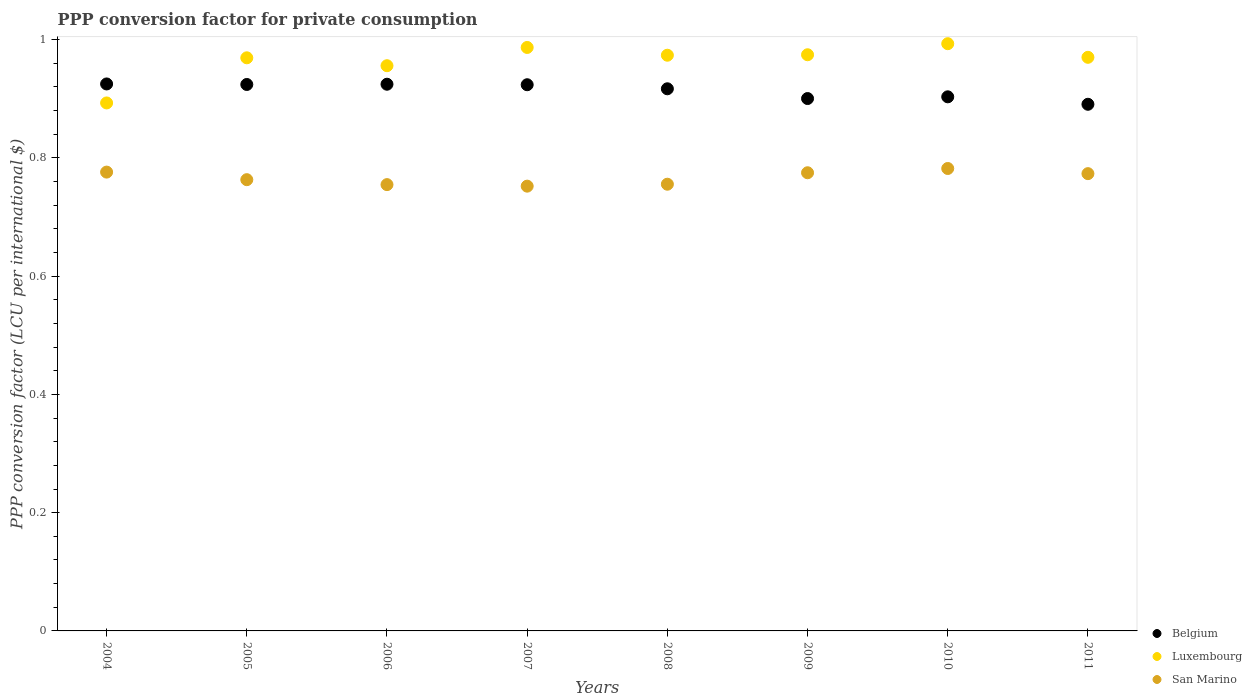What is the PPP conversion factor for private consumption in San Marino in 2004?
Provide a succinct answer. 0.78. Across all years, what is the maximum PPP conversion factor for private consumption in Luxembourg?
Ensure brevity in your answer.  0.99. Across all years, what is the minimum PPP conversion factor for private consumption in Luxembourg?
Your answer should be compact. 0.89. In which year was the PPP conversion factor for private consumption in Belgium maximum?
Your answer should be very brief. 2004. What is the total PPP conversion factor for private consumption in Belgium in the graph?
Ensure brevity in your answer.  7.31. What is the difference between the PPP conversion factor for private consumption in Luxembourg in 2004 and that in 2011?
Your answer should be compact. -0.08. What is the difference between the PPP conversion factor for private consumption in Luxembourg in 2006 and the PPP conversion factor for private consumption in Belgium in 2009?
Keep it short and to the point. 0.06. What is the average PPP conversion factor for private consumption in Luxembourg per year?
Keep it short and to the point. 0.96. In the year 2006, what is the difference between the PPP conversion factor for private consumption in San Marino and PPP conversion factor for private consumption in Luxembourg?
Make the answer very short. -0.2. In how many years, is the PPP conversion factor for private consumption in Luxembourg greater than 0.8400000000000001 LCU?
Your answer should be very brief. 8. What is the ratio of the PPP conversion factor for private consumption in Luxembourg in 2005 to that in 2009?
Keep it short and to the point. 0.99. Is the difference between the PPP conversion factor for private consumption in San Marino in 2006 and 2009 greater than the difference between the PPP conversion factor for private consumption in Luxembourg in 2006 and 2009?
Your answer should be very brief. No. What is the difference between the highest and the second highest PPP conversion factor for private consumption in San Marino?
Provide a succinct answer. 0.01. What is the difference between the highest and the lowest PPP conversion factor for private consumption in Luxembourg?
Provide a succinct answer. 0.1. In how many years, is the PPP conversion factor for private consumption in Belgium greater than the average PPP conversion factor for private consumption in Belgium taken over all years?
Offer a very short reply. 5. Is the sum of the PPP conversion factor for private consumption in San Marino in 2007 and 2011 greater than the maximum PPP conversion factor for private consumption in Luxembourg across all years?
Provide a short and direct response. Yes. Does the PPP conversion factor for private consumption in Luxembourg monotonically increase over the years?
Provide a short and direct response. No. How many dotlines are there?
Provide a short and direct response. 3. Does the graph contain any zero values?
Provide a succinct answer. No. How many legend labels are there?
Your answer should be compact. 3. How are the legend labels stacked?
Provide a succinct answer. Vertical. What is the title of the graph?
Your answer should be very brief. PPP conversion factor for private consumption. What is the label or title of the Y-axis?
Ensure brevity in your answer.  PPP conversion factor (LCU per international $). What is the PPP conversion factor (LCU per international $) of Belgium in 2004?
Offer a very short reply. 0.92. What is the PPP conversion factor (LCU per international $) of Luxembourg in 2004?
Offer a terse response. 0.89. What is the PPP conversion factor (LCU per international $) in San Marino in 2004?
Provide a short and direct response. 0.78. What is the PPP conversion factor (LCU per international $) in Belgium in 2005?
Provide a short and direct response. 0.92. What is the PPP conversion factor (LCU per international $) in Luxembourg in 2005?
Your answer should be very brief. 0.97. What is the PPP conversion factor (LCU per international $) in San Marino in 2005?
Provide a succinct answer. 0.76. What is the PPP conversion factor (LCU per international $) in Belgium in 2006?
Offer a terse response. 0.92. What is the PPP conversion factor (LCU per international $) of Luxembourg in 2006?
Give a very brief answer. 0.96. What is the PPP conversion factor (LCU per international $) of San Marino in 2006?
Make the answer very short. 0.75. What is the PPP conversion factor (LCU per international $) of Belgium in 2007?
Provide a short and direct response. 0.92. What is the PPP conversion factor (LCU per international $) of Luxembourg in 2007?
Offer a terse response. 0.99. What is the PPP conversion factor (LCU per international $) in San Marino in 2007?
Your response must be concise. 0.75. What is the PPP conversion factor (LCU per international $) in Belgium in 2008?
Provide a short and direct response. 0.92. What is the PPP conversion factor (LCU per international $) in Luxembourg in 2008?
Your answer should be very brief. 0.97. What is the PPP conversion factor (LCU per international $) in San Marino in 2008?
Ensure brevity in your answer.  0.76. What is the PPP conversion factor (LCU per international $) of Belgium in 2009?
Provide a short and direct response. 0.9. What is the PPP conversion factor (LCU per international $) in Luxembourg in 2009?
Give a very brief answer. 0.97. What is the PPP conversion factor (LCU per international $) of San Marino in 2009?
Keep it short and to the point. 0.77. What is the PPP conversion factor (LCU per international $) of Belgium in 2010?
Your answer should be very brief. 0.9. What is the PPP conversion factor (LCU per international $) in Luxembourg in 2010?
Your response must be concise. 0.99. What is the PPP conversion factor (LCU per international $) of San Marino in 2010?
Keep it short and to the point. 0.78. What is the PPP conversion factor (LCU per international $) of Belgium in 2011?
Make the answer very short. 0.89. What is the PPP conversion factor (LCU per international $) of Luxembourg in 2011?
Your answer should be compact. 0.97. What is the PPP conversion factor (LCU per international $) of San Marino in 2011?
Your answer should be compact. 0.77. Across all years, what is the maximum PPP conversion factor (LCU per international $) in Belgium?
Make the answer very short. 0.92. Across all years, what is the maximum PPP conversion factor (LCU per international $) of Luxembourg?
Your answer should be compact. 0.99. Across all years, what is the maximum PPP conversion factor (LCU per international $) of San Marino?
Offer a very short reply. 0.78. Across all years, what is the minimum PPP conversion factor (LCU per international $) of Belgium?
Your answer should be compact. 0.89. Across all years, what is the minimum PPP conversion factor (LCU per international $) in Luxembourg?
Make the answer very short. 0.89. Across all years, what is the minimum PPP conversion factor (LCU per international $) of San Marino?
Your answer should be compact. 0.75. What is the total PPP conversion factor (LCU per international $) in Belgium in the graph?
Provide a succinct answer. 7.31. What is the total PPP conversion factor (LCU per international $) of Luxembourg in the graph?
Your response must be concise. 7.72. What is the total PPP conversion factor (LCU per international $) in San Marino in the graph?
Your response must be concise. 6.13. What is the difference between the PPP conversion factor (LCU per international $) of Belgium in 2004 and that in 2005?
Offer a very short reply. 0. What is the difference between the PPP conversion factor (LCU per international $) of Luxembourg in 2004 and that in 2005?
Provide a succinct answer. -0.08. What is the difference between the PPP conversion factor (LCU per international $) in San Marino in 2004 and that in 2005?
Your response must be concise. 0.01. What is the difference between the PPP conversion factor (LCU per international $) of Luxembourg in 2004 and that in 2006?
Provide a succinct answer. -0.06. What is the difference between the PPP conversion factor (LCU per international $) in San Marino in 2004 and that in 2006?
Offer a very short reply. 0.02. What is the difference between the PPP conversion factor (LCU per international $) of Belgium in 2004 and that in 2007?
Provide a short and direct response. 0. What is the difference between the PPP conversion factor (LCU per international $) of Luxembourg in 2004 and that in 2007?
Your answer should be very brief. -0.09. What is the difference between the PPP conversion factor (LCU per international $) of San Marino in 2004 and that in 2007?
Provide a short and direct response. 0.02. What is the difference between the PPP conversion factor (LCU per international $) in Belgium in 2004 and that in 2008?
Provide a succinct answer. 0.01. What is the difference between the PPP conversion factor (LCU per international $) in Luxembourg in 2004 and that in 2008?
Your response must be concise. -0.08. What is the difference between the PPP conversion factor (LCU per international $) of San Marino in 2004 and that in 2008?
Offer a terse response. 0.02. What is the difference between the PPP conversion factor (LCU per international $) in Belgium in 2004 and that in 2009?
Make the answer very short. 0.02. What is the difference between the PPP conversion factor (LCU per international $) in Luxembourg in 2004 and that in 2009?
Ensure brevity in your answer.  -0.08. What is the difference between the PPP conversion factor (LCU per international $) in San Marino in 2004 and that in 2009?
Your answer should be compact. 0. What is the difference between the PPP conversion factor (LCU per international $) of Belgium in 2004 and that in 2010?
Make the answer very short. 0.02. What is the difference between the PPP conversion factor (LCU per international $) in Luxembourg in 2004 and that in 2010?
Your answer should be very brief. -0.1. What is the difference between the PPP conversion factor (LCU per international $) of San Marino in 2004 and that in 2010?
Provide a short and direct response. -0.01. What is the difference between the PPP conversion factor (LCU per international $) of Belgium in 2004 and that in 2011?
Your answer should be very brief. 0.03. What is the difference between the PPP conversion factor (LCU per international $) of Luxembourg in 2004 and that in 2011?
Provide a succinct answer. -0.08. What is the difference between the PPP conversion factor (LCU per international $) in San Marino in 2004 and that in 2011?
Make the answer very short. 0. What is the difference between the PPP conversion factor (LCU per international $) in Belgium in 2005 and that in 2006?
Ensure brevity in your answer.  -0. What is the difference between the PPP conversion factor (LCU per international $) in Luxembourg in 2005 and that in 2006?
Provide a short and direct response. 0.01. What is the difference between the PPP conversion factor (LCU per international $) in San Marino in 2005 and that in 2006?
Ensure brevity in your answer.  0.01. What is the difference between the PPP conversion factor (LCU per international $) in Luxembourg in 2005 and that in 2007?
Your answer should be very brief. -0.02. What is the difference between the PPP conversion factor (LCU per international $) in San Marino in 2005 and that in 2007?
Ensure brevity in your answer.  0.01. What is the difference between the PPP conversion factor (LCU per international $) in Belgium in 2005 and that in 2008?
Your answer should be very brief. 0.01. What is the difference between the PPP conversion factor (LCU per international $) in Luxembourg in 2005 and that in 2008?
Provide a succinct answer. -0. What is the difference between the PPP conversion factor (LCU per international $) of San Marino in 2005 and that in 2008?
Give a very brief answer. 0.01. What is the difference between the PPP conversion factor (LCU per international $) in Belgium in 2005 and that in 2009?
Keep it short and to the point. 0.02. What is the difference between the PPP conversion factor (LCU per international $) in Luxembourg in 2005 and that in 2009?
Offer a very short reply. -0.01. What is the difference between the PPP conversion factor (LCU per international $) in San Marino in 2005 and that in 2009?
Ensure brevity in your answer.  -0.01. What is the difference between the PPP conversion factor (LCU per international $) of Belgium in 2005 and that in 2010?
Keep it short and to the point. 0.02. What is the difference between the PPP conversion factor (LCU per international $) of Luxembourg in 2005 and that in 2010?
Your response must be concise. -0.02. What is the difference between the PPP conversion factor (LCU per international $) in San Marino in 2005 and that in 2010?
Ensure brevity in your answer.  -0.02. What is the difference between the PPP conversion factor (LCU per international $) of Belgium in 2005 and that in 2011?
Your answer should be very brief. 0.03. What is the difference between the PPP conversion factor (LCU per international $) of Luxembourg in 2005 and that in 2011?
Your response must be concise. -0. What is the difference between the PPP conversion factor (LCU per international $) in San Marino in 2005 and that in 2011?
Your answer should be very brief. -0.01. What is the difference between the PPP conversion factor (LCU per international $) of Belgium in 2006 and that in 2007?
Give a very brief answer. 0. What is the difference between the PPP conversion factor (LCU per international $) in Luxembourg in 2006 and that in 2007?
Offer a very short reply. -0.03. What is the difference between the PPP conversion factor (LCU per international $) of San Marino in 2006 and that in 2007?
Offer a terse response. 0. What is the difference between the PPP conversion factor (LCU per international $) in Belgium in 2006 and that in 2008?
Your answer should be compact. 0.01. What is the difference between the PPP conversion factor (LCU per international $) in Luxembourg in 2006 and that in 2008?
Ensure brevity in your answer.  -0.02. What is the difference between the PPP conversion factor (LCU per international $) in San Marino in 2006 and that in 2008?
Ensure brevity in your answer.  -0. What is the difference between the PPP conversion factor (LCU per international $) in Belgium in 2006 and that in 2009?
Your answer should be compact. 0.02. What is the difference between the PPP conversion factor (LCU per international $) in Luxembourg in 2006 and that in 2009?
Keep it short and to the point. -0.02. What is the difference between the PPP conversion factor (LCU per international $) in San Marino in 2006 and that in 2009?
Provide a succinct answer. -0.02. What is the difference between the PPP conversion factor (LCU per international $) in Belgium in 2006 and that in 2010?
Ensure brevity in your answer.  0.02. What is the difference between the PPP conversion factor (LCU per international $) in Luxembourg in 2006 and that in 2010?
Ensure brevity in your answer.  -0.04. What is the difference between the PPP conversion factor (LCU per international $) in San Marino in 2006 and that in 2010?
Offer a terse response. -0.03. What is the difference between the PPP conversion factor (LCU per international $) of Belgium in 2006 and that in 2011?
Offer a very short reply. 0.03. What is the difference between the PPP conversion factor (LCU per international $) in Luxembourg in 2006 and that in 2011?
Offer a very short reply. -0.01. What is the difference between the PPP conversion factor (LCU per international $) in San Marino in 2006 and that in 2011?
Your answer should be compact. -0.02. What is the difference between the PPP conversion factor (LCU per international $) of Belgium in 2007 and that in 2008?
Offer a very short reply. 0.01. What is the difference between the PPP conversion factor (LCU per international $) of Luxembourg in 2007 and that in 2008?
Your answer should be compact. 0.01. What is the difference between the PPP conversion factor (LCU per international $) in San Marino in 2007 and that in 2008?
Give a very brief answer. -0. What is the difference between the PPP conversion factor (LCU per international $) in Belgium in 2007 and that in 2009?
Provide a short and direct response. 0.02. What is the difference between the PPP conversion factor (LCU per international $) of Luxembourg in 2007 and that in 2009?
Make the answer very short. 0.01. What is the difference between the PPP conversion factor (LCU per international $) of San Marino in 2007 and that in 2009?
Make the answer very short. -0.02. What is the difference between the PPP conversion factor (LCU per international $) of Belgium in 2007 and that in 2010?
Give a very brief answer. 0.02. What is the difference between the PPP conversion factor (LCU per international $) of Luxembourg in 2007 and that in 2010?
Your answer should be very brief. -0.01. What is the difference between the PPP conversion factor (LCU per international $) of San Marino in 2007 and that in 2010?
Provide a short and direct response. -0.03. What is the difference between the PPP conversion factor (LCU per international $) in Belgium in 2007 and that in 2011?
Offer a very short reply. 0.03. What is the difference between the PPP conversion factor (LCU per international $) of Luxembourg in 2007 and that in 2011?
Offer a terse response. 0.02. What is the difference between the PPP conversion factor (LCU per international $) in San Marino in 2007 and that in 2011?
Give a very brief answer. -0.02. What is the difference between the PPP conversion factor (LCU per international $) of Belgium in 2008 and that in 2009?
Ensure brevity in your answer.  0.02. What is the difference between the PPP conversion factor (LCU per international $) of Luxembourg in 2008 and that in 2009?
Ensure brevity in your answer.  -0. What is the difference between the PPP conversion factor (LCU per international $) in San Marino in 2008 and that in 2009?
Your response must be concise. -0.02. What is the difference between the PPP conversion factor (LCU per international $) of Belgium in 2008 and that in 2010?
Make the answer very short. 0.01. What is the difference between the PPP conversion factor (LCU per international $) in Luxembourg in 2008 and that in 2010?
Your response must be concise. -0.02. What is the difference between the PPP conversion factor (LCU per international $) in San Marino in 2008 and that in 2010?
Make the answer very short. -0.03. What is the difference between the PPP conversion factor (LCU per international $) in Belgium in 2008 and that in 2011?
Your response must be concise. 0.03. What is the difference between the PPP conversion factor (LCU per international $) of Luxembourg in 2008 and that in 2011?
Your response must be concise. 0. What is the difference between the PPP conversion factor (LCU per international $) in San Marino in 2008 and that in 2011?
Your response must be concise. -0.02. What is the difference between the PPP conversion factor (LCU per international $) of Belgium in 2009 and that in 2010?
Provide a succinct answer. -0. What is the difference between the PPP conversion factor (LCU per international $) of Luxembourg in 2009 and that in 2010?
Your response must be concise. -0.02. What is the difference between the PPP conversion factor (LCU per international $) in San Marino in 2009 and that in 2010?
Keep it short and to the point. -0.01. What is the difference between the PPP conversion factor (LCU per international $) in Belgium in 2009 and that in 2011?
Ensure brevity in your answer.  0.01. What is the difference between the PPP conversion factor (LCU per international $) in Luxembourg in 2009 and that in 2011?
Your answer should be very brief. 0. What is the difference between the PPP conversion factor (LCU per international $) of San Marino in 2009 and that in 2011?
Give a very brief answer. 0. What is the difference between the PPP conversion factor (LCU per international $) in Belgium in 2010 and that in 2011?
Offer a terse response. 0.01. What is the difference between the PPP conversion factor (LCU per international $) of Luxembourg in 2010 and that in 2011?
Offer a terse response. 0.02. What is the difference between the PPP conversion factor (LCU per international $) of San Marino in 2010 and that in 2011?
Make the answer very short. 0.01. What is the difference between the PPP conversion factor (LCU per international $) of Belgium in 2004 and the PPP conversion factor (LCU per international $) of Luxembourg in 2005?
Make the answer very short. -0.04. What is the difference between the PPP conversion factor (LCU per international $) of Belgium in 2004 and the PPP conversion factor (LCU per international $) of San Marino in 2005?
Make the answer very short. 0.16. What is the difference between the PPP conversion factor (LCU per international $) of Luxembourg in 2004 and the PPP conversion factor (LCU per international $) of San Marino in 2005?
Your response must be concise. 0.13. What is the difference between the PPP conversion factor (LCU per international $) in Belgium in 2004 and the PPP conversion factor (LCU per international $) in Luxembourg in 2006?
Make the answer very short. -0.03. What is the difference between the PPP conversion factor (LCU per international $) in Belgium in 2004 and the PPP conversion factor (LCU per international $) in San Marino in 2006?
Give a very brief answer. 0.17. What is the difference between the PPP conversion factor (LCU per international $) in Luxembourg in 2004 and the PPP conversion factor (LCU per international $) in San Marino in 2006?
Ensure brevity in your answer.  0.14. What is the difference between the PPP conversion factor (LCU per international $) in Belgium in 2004 and the PPP conversion factor (LCU per international $) in Luxembourg in 2007?
Keep it short and to the point. -0.06. What is the difference between the PPP conversion factor (LCU per international $) in Belgium in 2004 and the PPP conversion factor (LCU per international $) in San Marino in 2007?
Provide a short and direct response. 0.17. What is the difference between the PPP conversion factor (LCU per international $) in Luxembourg in 2004 and the PPP conversion factor (LCU per international $) in San Marino in 2007?
Offer a very short reply. 0.14. What is the difference between the PPP conversion factor (LCU per international $) of Belgium in 2004 and the PPP conversion factor (LCU per international $) of Luxembourg in 2008?
Make the answer very short. -0.05. What is the difference between the PPP conversion factor (LCU per international $) of Belgium in 2004 and the PPP conversion factor (LCU per international $) of San Marino in 2008?
Make the answer very short. 0.17. What is the difference between the PPP conversion factor (LCU per international $) of Luxembourg in 2004 and the PPP conversion factor (LCU per international $) of San Marino in 2008?
Keep it short and to the point. 0.14. What is the difference between the PPP conversion factor (LCU per international $) in Belgium in 2004 and the PPP conversion factor (LCU per international $) in Luxembourg in 2009?
Make the answer very short. -0.05. What is the difference between the PPP conversion factor (LCU per international $) in Belgium in 2004 and the PPP conversion factor (LCU per international $) in San Marino in 2009?
Give a very brief answer. 0.15. What is the difference between the PPP conversion factor (LCU per international $) of Luxembourg in 2004 and the PPP conversion factor (LCU per international $) of San Marino in 2009?
Give a very brief answer. 0.12. What is the difference between the PPP conversion factor (LCU per international $) of Belgium in 2004 and the PPP conversion factor (LCU per international $) of Luxembourg in 2010?
Give a very brief answer. -0.07. What is the difference between the PPP conversion factor (LCU per international $) in Belgium in 2004 and the PPP conversion factor (LCU per international $) in San Marino in 2010?
Ensure brevity in your answer.  0.14. What is the difference between the PPP conversion factor (LCU per international $) of Luxembourg in 2004 and the PPP conversion factor (LCU per international $) of San Marino in 2010?
Keep it short and to the point. 0.11. What is the difference between the PPP conversion factor (LCU per international $) of Belgium in 2004 and the PPP conversion factor (LCU per international $) of Luxembourg in 2011?
Provide a succinct answer. -0.04. What is the difference between the PPP conversion factor (LCU per international $) of Belgium in 2004 and the PPP conversion factor (LCU per international $) of San Marino in 2011?
Keep it short and to the point. 0.15. What is the difference between the PPP conversion factor (LCU per international $) of Luxembourg in 2004 and the PPP conversion factor (LCU per international $) of San Marino in 2011?
Give a very brief answer. 0.12. What is the difference between the PPP conversion factor (LCU per international $) in Belgium in 2005 and the PPP conversion factor (LCU per international $) in Luxembourg in 2006?
Offer a very short reply. -0.03. What is the difference between the PPP conversion factor (LCU per international $) of Belgium in 2005 and the PPP conversion factor (LCU per international $) of San Marino in 2006?
Your answer should be compact. 0.17. What is the difference between the PPP conversion factor (LCU per international $) of Luxembourg in 2005 and the PPP conversion factor (LCU per international $) of San Marino in 2006?
Provide a short and direct response. 0.21. What is the difference between the PPP conversion factor (LCU per international $) in Belgium in 2005 and the PPP conversion factor (LCU per international $) in Luxembourg in 2007?
Offer a terse response. -0.06. What is the difference between the PPP conversion factor (LCU per international $) of Belgium in 2005 and the PPP conversion factor (LCU per international $) of San Marino in 2007?
Your answer should be compact. 0.17. What is the difference between the PPP conversion factor (LCU per international $) of Luxembourg in 2005 and the PPP conversion factor (LCU per international $) of San Marino in 2007?
Ensure brevity in your answer.  0.22. What is the difference between the PPP conversion factor (LCU per international $) of Belgium in 2005 and the PPP conversion factor (LCU per international $) of Luxembourg in 2008?
Your response must be concise. -0.05. What is the difference between the PPP conversion factor (LCU per international $) of Belgium in 2005 and the PPP conversion factor (LCU per international $) of San Marino in 2008?
Give a very brief answer. 0.17. What is the difference between the PPP conversion factor (LCU per international $) of Luxembourg in 2005 and the PPP conversion factor (LCU per international $) of San Marino in 2008?
Make the answer very short. 0.21. What is the difference between the PPP conversion factor (LCU per international $) of Belgium in 2005 and the PPP conversion factor (LCU per international $) of Luxembourg in 2009?
Offer a very short reply. -0.05. What is the difference between the PPP conversion factor (LCU per international $) in Belgium in 2005 and the PPP conversion factor (LCU per international $) in San Marino in 2009?
Provide a short and direct response. 0.15. What is the difference between the PPP conversion factor (LCU per international $) of Luxembourg in 2005 and the PPP conversion factor (LCU per international $) of San Marino in 2009?
Keep it short and to the point. 0.19. What is the difference between the PPP conversion factor (LCU per international $) of Belgium in 2005 and the PPP conversion factor (LCU per international $) of Luxembourg in 2010?
Your answer should be compact. -0.07. What is the difference between the PPP conversion factor (LCU per international $) of Belgium in 2005 and the PPP conversion factor (LCU per international $) of San Marino in 2010?
Offer a very short reply. 0.14. What is the difference between the PPP conversion factor (LCU per international $) of Luxembourg in 2005 and the PPP conversion factor (LCU per international $) of San Marino in 2010?
Provide a succinct answer. 0.19. What is the difference between the PPP conversion factor (LCU per international $) in Belgium in 2005 and the PPP conversion factor (LCU per international $) in Luxembourg in 2011?
Provide a succinct answer. -0.05. What is the difference between the PPP conversion factor (LCU per international $) of Belgium in 2005 and the PPP conversion factor (LCU per international $) of San Marino in 2011?
Make the answer very short. 0.15. What is the difference between the PPP conversion factor (LCU per international $) of Luxembourg in 2005 and the PPP conversion factor (LCU per international $) of San Marino in 2011?
Your answer should be compact. 0.2. What is the difference between the PPP conversion factor (LCU per international $) in Belgium in 2006 and the PPP conversion factor (LCU per international $) in Luxembourg in 2007?
Provide a succinct answer. -0.06. What is the difference between the PPP conversion factor (LCU per international $) of Belgium in 2006 and the PPP conversion factor (LCU per international $) of San Marino in 2007?
Provide a succinct answer. 0.17. What is the difference between the PPP conversion factor (LCU per international $) in Luxembourg in 2006 and the PPP conversion factor (LCU per international $) in San Marino in 2007?
Offer a terse response. 0.2. What is the difference between the PPP conversion factor (LCU per international $) of Belgium in 2006 and the PPP conversion factor (LCU per international $) of Luxembourg in 2008?
Provide a short and direct response. -0.05. What is the difference between the PPP conversion factor (LCU per international $) in Belgium in 2006 and the PPP conversion factor (LCU per international $) in San Marino in 2008?
Your answer should be very brief. 0.17. What is the difference between the PPP conversion factor (LCU per international $) of Luxembourg in 2006 and the PPP conversion factor (LCU per international $) of San Marino in 2008?
Provide a short and direct response. 0.2. What is the difference between the PPP conversion factor (LCU per international $) in Belgium in 2006 and the PPP conversion factor (LCU per international $) in Luxembourg in 2009?
Keep it short and to the point. -0.05. What is the difference between the PPP conversion factor (LCU per international $) of Belgium in 2006 and the PPP conversion factor (LCU per international $) of San Marino in 2009?
Give a very brief answer. 0.15. What is the difference between the PPP conversion factor (LCU per international $) of Luxembourg in 2006 and the PPP conversion factor (LCU per international $) of San Marino in 2009?
Keep it short and to the point. 0.18. What is the difference between the PPP conversion factor (LCU per international $) in Belgium in 2006 and the PPP conversion factor (LCU per international $) in Luxembourg in 2010?
Give a very brief answer. -0.07. What is the difference between the PPP conversion factor (LCU per international $) of Belgium in 2006 and the PPP conversion factor (LCU per international $) of San Marino in 2010?
Make the answer very short. 0.14. What is the difference between the PPP conversion factor (LCU per international $) in Luxembourg in 2006 and the PPP conversion factor (LCU per international $) in San Marino in 2010?
Provide a short and direct response. 0.17. What is the difference between the PPP conversion factor (LCU per international $) in Belgium in 2006 and the PPP conversion factor (LCU per international $) in Luxembourg in 2011?
Offer a very short reply. -0.05. What is the difference between the PPP conversion factor (LCU per international $) of Belgium in 2006 and the PPP conversion factor (LCU per international $) of San Marino in 2011?
Offer a terse response. 0.15. What is the difference between the PPP conversion factor (LCU per international $) in Luxembourg in 2006 and the PPP conversion factor (LCU per international $) in San Marino in 2011?
Ensure brevity in your answer.  0.18. What is the difference between the PPP conversion factor (LCU per international $) of Belgium in 2007 and the PPP conversion factor (LCU per international $) of Luxembourg in 2008?
Ensure brevity in your answer.  -0.05. What is the difference between the PPP conversion factor (LCU per international $) in Belgium in 2007 and the PPP conversion factor (LCU per international $) in San Marino in 2008?
Offer a very short reply. 0.17. What is the difference between the PPP conversion factor (LCU per international $) in Luxembourg in 2007 and the PPP conversion factor (LCU per international $) in San Marino in 2008?
Make the answer very short. 0.23. What is the difference between the PPP conversion factor (LCU per international $) of Belgium in 2007 and the PPP conversion factor (LCU per international $) of Luxembourg in 2009?
Keep it short and to the point. -0.05. What is the difference between the PPP conversion factor (LCU per international $) of Belgium in 2007 and the PPP conversion factor (LCU per international $) of San Marino in 2009?
Provide a short and direct response. 0.15. What is the difference between the PPP conversion factor (LCU per international $) of Luxembourg in 2007 and the PPP conversion factor (LCU per international $) of San Marino in 2009?
Offer a terse response. 0.21. What is the difference between the PPP conversion factor (LCU per international $) of Belgium in 2007 and the PPP conversion factor (LCU per international $) of Luxembourg in 2010?
Offer a terse response. -0.07. What is the difference between the PPP conversion factor (LCU per international $) in Belgium in 2007 and the PPP conversion factor (LCU per international $) in San Marino in 2010?
Provide a short and direct response. 0.14. What is the difference between the PPP conversion factor (LCU per international $) in Luxembourg in 2007 and the PPP conversion factor (LCU per international $) in San Marino in 2010?
Your answer should be compact. 0.2. What is the difference between the PPP conversion factor (LCU per international $) of Belgium in 2007 and the PPP conversion factor (LCU per international $) of Luxembourg in 2011?
Your response must be concise. -0.05. What is the difference between the PPP conversion factor (LCU per international $) in Belgium in 2007 and the PPP conversion factor (LCU per international $) in San Marino in 2011?
Provide a succinct answer. 0.15. What is the difference between the PPP conversion factor (LCU per international $) of Luxembourg in 2007 and the PPP conversion factor (LCU per international $) of San Marino in 2011?
Offer a terse response. 0.21. What is the difference between the PPP conversion factor (LCU per international $) of Belgium in 2008 and the PPP conversion factor (LCU per international $) of Luxembourg in 2009?
Keep it short and to the point. -0.06. What is the difference between the PPP conversion factor (LCU per international $) in Belgium in 2008 and the PPP conversion factor (LCU per international $) in San Marino in 2009?
Your answer should be very brief. 0.14. What is the difference between the PPP conversion factor (LCU per international $) in Luxembourg in 2008 and the PPP conversion factor (LCU per international $) in San Marino in 2009?
Keep it short and to the point. 0.2. What is the difference between the PPP conversion factor (LCU per international $) in Belgium in 2008 and the PPP conversion factor (LCU per international $) in Luxembourg in 2010?
Your response must be concise. -0.08. What is the difference between the PPP conversion factor (LCU per international $) of Belgium in 2008 and the PPP conversion factor (LCU per international $) of San Marino in 2010?
Your answer should be compact. 0.13. What is the difference between the PPP conversion factor (LCU per international $) in Luxembourg in 2008 and the PPP conversion factor (LCU per international $) in San Marino in 2010?
Your response must be concise. 0.19. What is the difference between the PPP conversion factor (LCU per international $) in Belgium in 2008 and the PPP conversion factor (LCU per international $) in Luxembourg in 2011?
Offer a terse response. -0.05. What is the difference between the PPP conversion factor (LCU per international $) of Belgium in 2008 and the PPP conversion factor (LCU per international $) of San Marino in 2011?
Ensure brevity in your answer.  0.14. What is the difference between the PPP conversion factor (LCU per international $) of Luxembourg in 2008 and the PPP conversion factor (LCU per international $) of San Marino in 2011?
Give a very brief answer. 0.2. What is the difference between the PPP conversion factor (LCU per international $) of Belgium in 2009 and the PPP conversion factor (LCU per international $) of Luxembourg in 2010?
Make the answer very short. -0.09. What is the difference between the PPP conversion factor (LCU per international $) in Belgium in 2009 and the PPP conversion factor (LCU per international $) in San Marino in 2010?
Your answer should be compact. 0.12. What is the difference between the PPP conversion factor (LCU per international $) in Luxembourg in 2009 and the PPP conversion factor (LCU per international $) in San Marino in 2010?
Your response must be concise. 0.19. What is the difference between the PPP conversion factor (LCU per international $) in Belgium in 2009 and the PPP conversion factor (LCU per international $) in Luxembourg in 2011?
Make the answer very short. -0.07. What is the difference between the PPP conversion factor (LCU per international $) of Belgium in 2009 and the PPP conversion factor (LCU per international $) of San Marino in 2011?
Offer a very short reply. 0.13. What is the difference between the PPP conversion factor (LCU per international $) in Luxembourg in 2009 and the PPP conversion factor (LCU per international $) in San Marino in 2011?
Your answer should be very brief. 0.2. What is the difference between the PPP conversion factor (LCU per international $) of Belgium in 2010 and the PPP conversion factor (LCU per international $) of Luxembourg in 2011?
Provide a succinct answer. -0.07. What is the difference between the PPP conversion factor (LCU per international $) in Belgium in 2010 and the PPP conversion factor (LCU per international $) in San Marino in 2011?
Provide a succinct answer. 0.13. What is the difference between the PPP conversion factor (LCU per international $) in Luxembourg in 2010 and the PPP conversion factor (LCU per international $) in San Marino in 2011?
Give a very brief answer. 0.22. What is the average PPP conversion factor (LCU per international $) in Belgium per year?
Ensure brevity in your answer.  0.91. What is the average PPP conversion factor (LCU per international $) of Luxembourg per year?
Give a very brief answer. 0.96. What is the average PPP conversion factor (LCU per international $) in San Marino per year?
Make the answer very short. 0.77. In the year 2004, what is the difference between the PPP conversion factor (LCU per international $) in Belgium and PPP conversion factor (LCU per international $) in Luxembourg?
Provide a succinct answer. 0.03. In the year 2004, what is the difference between the PPP conversion factor (LCU per international $) of Belgium and PPP conversion factor (LCU per international $) of San Marino?
Ensure brevity in your answer.  0.15. In the year 2004, what is the difference between the PPP conversion factor (LCU per international $) in Luxembourg and PPP conversion factor (LCU per international $) in San Marino?
Make the answer very short. 0.12. In the year 2005, what is the difference between the PPP conversion factor (LCU per international $) of Belgium and PPP conversion factor (LCU per international $) of Luxembourg?
Your response must be concise. -0.05. In the year 2005, what is the difference between the PPP conversion factor (LCU per international $) in Belgium and PPP conversion factor (LCU per international $) in San Marino?
Your answer should be compact. 0.16. In the year 2005, what is the difference between the PPP conversion factor (LCU per international $) of Luxembourg and PPP conversion factor (LCU per international $) of San Marino?
Provide a succinct answer. 0.21. In the year 2006, what is the difference between the PPP conversion factor (LCU per international $) in Belgium and PPP conversion factor (LCU per international $) in Luxembourg?
Give a very brief answer. -0.03. In the year 2006, what is the difference between the PPP conversion factor (LCU per international $) of Belgium and PPP conversion factor (LCU per international $) of San Marino?
Your answer should be compact. 0.17. In the year 2006, what is the difference between the PPP conversion factor (LCU per international $) in Luxembourg and PPP conversion factor (LCU per international $) in San Marino?
Make the answer very short. 0.2. In the year 2007, what is the difference between the PPP conversion factor (LCU per international $) of Belgium and PPP conversion factor (LCU per international $) of Luxembourg?
Your answer should be very brief. -0.06. In the year 2007, what is the difference between the PPP conversion factor (LCU per international $) in Belgium and PPP conversion factor (LCU per international $) in San Marino?
Ensure brevity in your answer.  0.17. In the year 2007, what is the difference between the PPP conversion factor (LCU per international $) in Luxembourg and PPP conversion factor (LCU per international $) in San Marino?
Provide a succinct answer. 0.23. In the year 2008, what is the difference between the PPP conversion factor (LCU per international $) in Belgium and PPP conversion factor (LCU per international $) in Luxembourg?
Keep it short and to the point. -0.06. In the year 2008, what is the difference between the PPP conversion factor (LCU per international $) in Belgium and PPP conversion factor (LCU per international $) in San Marino?
Ensure brevity in your answer.  0.16. In the year 2008, what is the difference between the PPP conversion factor (LCU per international $) in Luxembourg and PPP conversion factor (LCU per international $) in San Marino?
Offer a very short reply. 0.22. In the year 2009, what is the difference between the PPP conversion factor (LCU per international $) in Belgium and PPP conversion factor (LCU per international $) in Luxembourg?
Make the answer very short. -0.07. In the year 2009, what is the difference between the PPP conversion factor (LCU per international $) in Belgium and PPP conversion factor (LCU per international $) in San Marino?
Provide a short and direct response. 0.13. In the year 2009, what is the difference between the PPP conversion factor (LCU per international $) in Luxembourg and PPP conversion factor (LCU per international $) in San Marino?
Offer a very short reply. 0.2. In the year 2010, what is the difference between the PPP conversion factor (LCU per international $) of Belgium and PPP conversion factor (LCU per international $) of Luxembourg?
Provide a short and direct response. -0.09. In the year 2010, what is the difference between the PPP conversion factor (LCU per international $) in Belgium and PPP conversion factor (LCU per international $) in San Marino?
Offer a very short reply. 0.12. In the year 2010, what is the difference between the PPP conversion factor (LCU per international $) in Luxembourg and PPP conversion factor (LCU per international $) in San Marino?
Offer a very short reply. 0.21. In the year 2011, what is the difference between the PPP conversion factor (LCU per international $) in Belgium and PPP conversion factor (LCU per international $) in Luxembourg?
Keep it short and to the point. -0.08. In the year 2011, what is the difference between the PPP conversion factor (LCU per international $) in Belgium and PPP conversion factor (LCU per international $) in San Marino?
Offer a terse response. 0.12. In the year 2011, what is the difference between the PPP conversion factor (LCU per international $) in Luxembourg and PPP conversion factor (LCU per international $) in San Marino?
Your answer should be compact. 0.2. What is the ratio of the PPP conversion factor (LCU per international $) of Belgium in 2004 to that in 2005?
Your answer should be very brief. 1. What is the ratio of the PPP conversion factor (LCU per international $) of Luxembourg in 2004 to that in 2005?
Keep it short and to the point. 0.92. What is the ratio of the PPP conversion factor (LCU per international $) of San Marino in 2004 to that in 2005?
Make the answer very short. 1.02. What is the ratio of the PPP conversion factor (LCU per international $) in Belgium in 2004 to that in 2006?
Keep it short and to the point. 1. What is the ratio of the PPP conversion factor (LCU per international $) of Luxembourg in 2004 to that in 2006?
Offer a terse response. 0.93. What is the ratio of the PPP conversion factor (LCU per international $) of San Marino in 2004 to that in 2006?
Your response must be concise. 1.03. What is the ratio of the PPP conversion factor (LCU per international $) in Luxembourg in 2004 to that in 2007?
Provide a succinct answer. 0.9. What is the ratio of the PPP conversion factor (LCU per international $) of San Marino in 2004 to that in 2007?
Offer a terse response. 1.03. What is the ratio of the PPP conversion factor (LCU per international $) in Belgium in 2004 to that in 2008?
Your response must be concise. 1.01. What is the ratio of the PPP conversion factor (LCU per international $) of Luxembourg in 2004 to that in 2008?
Give a very brief answer. 0.92. What is the ratio of the PPP conversion factor (LCU per international $) of San Marino in 2004 to that in 2008?
Offer a very short reply. 1.03. What is the ratio of the PPP conversion factor (LCU per international $) of Belgium in 2004 to that in 2009?
Your response must be concise. 1.03. What is the ratio of the PPP conversion factor (LCU per international $) of Luxembourg in 2004 to that in 2009?
Make the answer very short. 0.92. What is the ratio of the PPP conversion factor (LCU per international $) in Belgium in 2004 to that in 2010?
Your answer should be compact. 1.02. What is the ratio of the PPP conversion factor (LCU per international $) in Luxembourg in 2004 to that in 2010?
Keep it short and to the point. 0.9. What is the ratio of the PPP conversion factor (LCU per international $) in San Marino in 2004 to that in 2010?
Make the answer very short. 0.99. What is the ratio of the PPP conversion factor (LCU per international $) in Belgium in 2004 to that in 2011?
Your answer should be very brief. 1.04. What is the ratio of the PPP conversion factor (LCU per international $) in Luxembourg in 2004 to that in 2011?
Your answer should be very brief. 0.92. What is the ratio of the PPP conversion factor (LCU per international $) in San Marino in 2004 to that in 2011?
Provide a short and direct response. 1. What is the ratio of the PPP conversion factor (LCU per international $) in Belgium in 2005 to that in 2006?
Your answer should be very brief. 1. What is the ratio of the PPP conversion factor (LCU per international $) of San Marino in 2005 to that in 2006?
Your answer should be compact. 1.01. What is the ratio of the PPP conversion factor (LCU per international $) of Luxembourg in 2005 to that in 2007?
Give a very brief answer. 0.98. What is the ratio of the PPP conversion factor (LCU per international $) of San Marino in 2005 to that in 2007?
Provide a succinct answer. 1.01. What is the ratio of the PPP conversion factor (LCU per international $) in Belgium in 2005 to that in 2008?
Keep it short and to the point. 1.01. What is the ratio of the PPP conversion factor (LCU per international $) of Luxembourg in 2005 to that in 2008?
Make the answer very short. 1. What is the ratio of the PPP conversion factor (LCU per international $) in San Marino in 2005 to that in 2008?
Make the answer very short. 1.01. What is the ratio of the PPP conversion factor (LCU per international $) of Belgium in 2005 to that in 2009?
Offer a very short reply. 1.03. What is the ratio of the PPP conversion factor (LCU per international $) of San Marino in 2005 to that in 2009?
Your answer should be very brief. 0.98. What is the ratio of the PPP conversion factor (LCU per international $) in Belgium in 2005 to that in 2010?
Provide a short and direct response. 1.02. What is the ratio of the PPP conversion factor (LCU per international $) of Luxembourg in 2005 to that in 2010?
Offer a terse response. 0.98. What is the ratio of the PPP conversion factor (LCU per international $) of San Marino in 2005 to that in 2010?
Make the answer very short. 0.98. What is the ratio of the PPP conversion factor (LCU per international $) of Belgium in 2005 to that in 2011?
Your response must be concise. 1.04. What is the ratio of the PPP conversion factor (LCU per international $) in Luxembourg in 2005 to that in 2011?
Your answer should be compact. 1. What is the ratio of the PPP conversion factor (LCU per international $) of San Marino in 2005 to that in 2011?
Your answer should be very brief. 0.99. What is the ratio of the PPP conversion factor (LCU per international $) in Luxembourg in 2006 to that in 2007?
Make the answer very short. 0.97. What is the ratio of the PPP conversion factor (LCU per international $) in Belgium in 2006 to that in 2008?
Your response must be concise. 1.01. What is the ratio of the PPP conversion factor (LCU per international $) of Luxembourg in 2006 to that in 2008?
Give a very brief answer. 0.98. What is the ratio of the PPP conversion factor (LCU per international $) of Belgium in 2006 to that in 2009?
Ensure brevity in your answer.  1.03. What is the ratio of the PPP conversion factor (LCU per international $) of Luxembourg in 2006 to that in 2009?
Provide a short and direct response. 0.98. What is the ratio of the PPP conversion factor (LCU per international $) of San Marino in 2006 to that in 2009?
Provide a short and direct response. 0.97. What is the ratio of the PPP conversion factor (LCU per international $) of Belgium in 2006 to that in 2010?
Make the answer very short. 1.02. What is the ratio of the PPP conversion factor (LCU per international $) in Luxembourg in 2006 to that in 2010?
Provide a succinct answer. 0.96. What is the ratio of the PPP conversion factor (LCU per international $) in San Marino in 2006 to that in 2010?
Provide a short and direct response. 0.97. What is the ratio of the PPP conversion factor (LCU per international $) of Belgium in 2006 to that in 2011?
Keep it short and to the point. 1.04. What is the ratio of the PPP conversion factor (LCU per international $) in Luxembourg in 2006 to that in 2011?
Offer a very short reply. 0.99. What is the ratio of the PPP conversion factor (LCU per international $) of San Marino in 2006 to that in 2011?
Give a very brief answer. 0.98. What is the ratio of the PPP conversion factor (LCU per international $) in Belgium in 2007 to that in 2008?
Your answer should be very brief. 1.01. What is the ratio of the PPP conversion factor (LCU per international $) in Luxembourg in 2007 to that in 2008?
Offer a terse response. 1.01. What is the ratio of the PPP conversion factor (LCU per international $) in San Marino in 2007 to that in 2008?
Give a very brief answer. 1. What is the ratio of the PPP conversion factor (LCU per international $) in Belgium in 2007 to that in 2009?
Your response must be concise. 1.03. What is the ratio of the PPP conversion factor (LCU per international $) in Luxembourg in 2007 to that in 2009?
Offer a terse response. 1.01. What is the ratio of the PPP conversion factor (LCU per international $) in San Marino in 2007 to that in 2009?
Make the answer very short. 0.97. What is the ratio of the PPP conversion factor (LCU per international $) in Belgium in 2007 to that in 2010?
Your answer should be compact. 1.02. What is the ratio of the PPP conversion factor (LCU per international $) in San Marino in 2007 to that in 2010?
Keep it short and to the point. 0.96. What is the ratio of the PPP conversion factor (LCU per international $) of Belgium in 2007 to that in 2011?
Provide a succinct answer. 1.04. What is the ratio of the PPP conversion factor (LCU per international $) in Luxembourg in 2007 to that in 2011?
Keep it short and to the point. 1.02. What is the ratio of the PPP conversion factor (LCU per international $) of San Marino in 2007 to that in 2011?
Keep it short and to the point. 0.97. What is the ratio of the PPP conversion factor (LCU per international $) of Belgium in 2008 to that in 2009?
Your answer should be very brief. 1.02. What is the ratio of the PPP conversion factor (LCU per international $) in Belgium in 2008 to that in 2010?
Offer a very short reply. 1.02. What is the ratio of the PPP conversion factor (LCU per international $) of Luxembourg in 2008 to that in 2010?
Offer a terse response. 0.98. What is the ratio of the PPP conversion factor (LCU per international $) of San Marino in 2008 to that in 2010?
Give a very brief answer. 0.97. What is the ratio of the PPP conversion factor (LCU per international $) in Belgium in 2008 to that in 2011?
Offer a terse response. 1.03. What is the ratio of the PPP conversion factor (LCU per international $) in Luxembourg in 2008 to that in 2011?
Your response must be concise. 1. What is the ratio of the PPP conversion factor (LCU per international $) of San Marino in 2008 to that in 2011?
Your answer should be compact. 0.98. What is the ratio of the PPP conversion factor (LCU per international $) in Belgium in 2009 to that in 2010?
Your answer should be compact. 1. What is the ratio of the PPP conversion factor (LCU per international $) of Luxembourg in 2009 to that in 2010?
Offer a very short reply. 0.98. What is the ratio of the PPP conversion factor (LCU per international $) of Belgium in 2009 to that in 2011?
Provide a short and direct response. 1.01. What is the ratio of the PPP conversion factor (LCU per international $) of San Marino in 2009 to that in 2011?
Offer a very short reply. 1. What is the ratio of the PPP conversion factor (LCU per international $) of Belgium in 2010 to that in 2011?
Your answer should be very brief. 1.01. What is the ratio of the PPP conversion factor (LCU per international $) in Luxembourg in 2010 to that in 2011?
Ensure brevity in your answer.  1.02. What is the ratio of the PPP conversion factor (LCU per international $) in San Marino in 2010 to that in 2011?
Provide a short and direct response. 1.01. What is the difference between the highest and the second highest PPP conversion factor (LCU per international $) of Belgium?
Your answer should be compact. 0. What is the difference between the highest and the second highest PPP conversion factor (LCU per international $) in Luxembourg?
Your response must be concise. 0.01. What is the difference between the highest and the second highest PPP conversion factor (LCU per international $) in San Marino?
Keep it short and to the point. 0.01. What is the difference between the highest and the lowest PPP conversion factor (LCU per international $) in Belgium?
Provide a short and direct response. 0.03. What is the difference between the highest and the lowest PPP conversion factor (LCU per international $) in Luxembourg?
Keep it short and to the point. 0.1. What is the difference between the highest and the lowest PPP conversion factor (LCU per international $) of San Marino?
Your response must be concise. 0.03. 